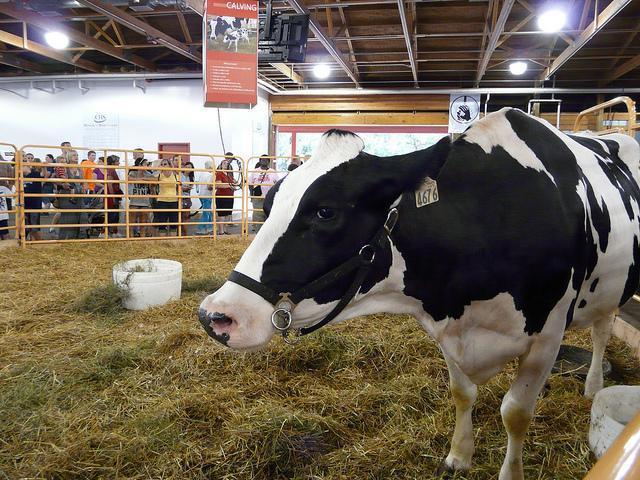How many cows can you see?
Give a very brief answer. 1. 